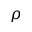<formula> <loc_0><loc_0><loc_500><loc_500>\rho</formula> 